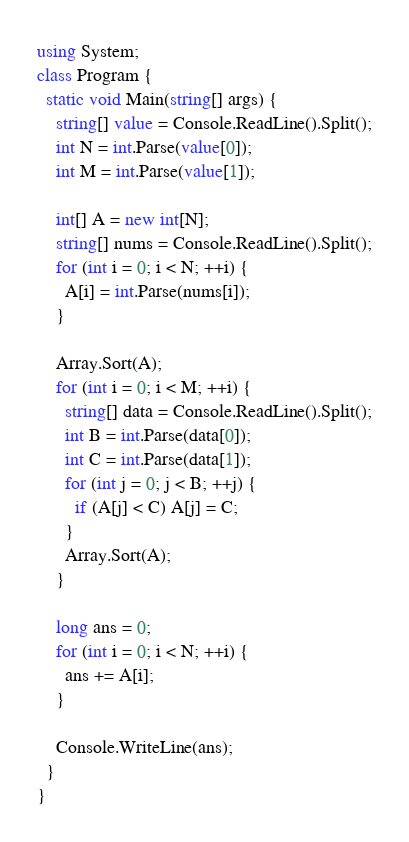Convert code to text. <code><loc_0><loc_0><loc_500><loc_500><_C#_>using System;
class Program {
  static void Main(string[] args) {
    string[] value = Console.ReadLine().Split();
    int N = int.Parse(value[0]);
    int M = int.Parse(value[1]);

    int[] A = new int[N];
    string[] nums = Console.ReadLine().Split();
    for (int i = 0; i < N; ++i) {
      A[i] = int.Parse(nums[i]);
    }

    Array.Sort(A);
    for (int i = 0; i < M; ++i) {
      string[] data = Console.ReadLine().Split();
      int B = int.Parse(data[0]);
      int C = int.Parse(data[1]);
      for (int j = 0; j < B; ++j) {
        if (A[j] < C) A[j] = C;
      }
      Array.Sort(A);
    }

    long ans = 0;
    for (int i = 0; i < N; ++i) {
      ans += A[i];
    }

    Console.WriteLine(ans);
  }
}
</code> 